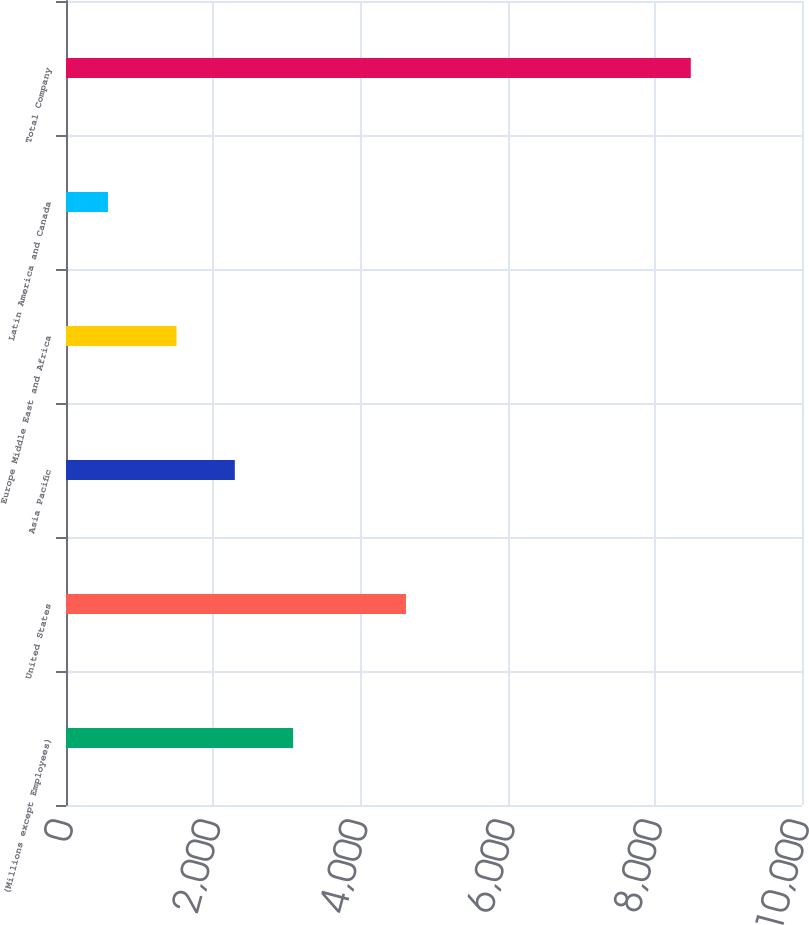<chart> <loc_0><loc_0><loc_500><loc_500><bar_chart><fcel>(Millions except Employees)<fcel>United States<fcel>Asia Pacific<fcel>Europe Middle East and Africa<fcel>Latin America and Canada<fcel>Total Company<nl><fcel>3085.8<fcel>4619<fcel>2293.9<fcel>1502<fcel>570<fcel>8489<nl></chart> 